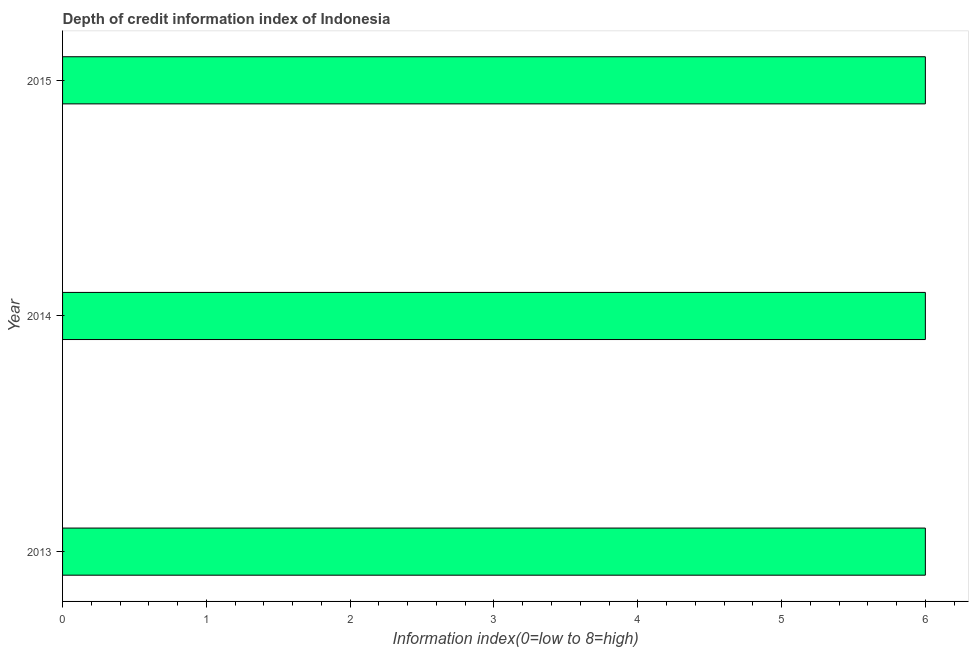Does the graph contain any zero values?
Your answer should be very brief. No. What is the title of the graph?
Your response must be concise. Depth of credit information index of Indonesia. What is the label or title of the X-axis?
Your answer should be very brief. Information index(0=low to 8=high). What is the label or title of the Y-axis?
Keep it short and to the point. Year. What is the depth of credit information index in 2013?
Your answer should be compact. 6. Across all years, what is the minimum depth of credit information index?
Give a very brief answer. 6. What is the average depth of credit information index per year?
Provide a short and direct response. 6. What is the median depth of credit information index?
Make the answer very short. 6. Do a majority of the years between 2014 and 2013 (inclusive) have depth of credit information index greater than 2.2 ?
Provide a short and direct response. No. What is the ratio of the depth of credit information index in 2013 to that in 2015?
Keep it short and to the point. 1. Is the depth of credit information index in 2014 less than that in 2015?
Offer a very short reply. No. Is the sum of the depth of credit information index in 2013 and 2015 greater than the maximum depth of credit information index across all years?
Keep it short and to the point. Yes. What is the difference between the highest and the lowest depth of credit information index?
Your answer should be compact. 0. In how many years, is the depth of credit information index greater than the average depth of credit information index taken over all years?
Make the answer very short. 0. How many bars are there?
Offer a very short reply. 3. How many years are there in the graph?
Provide a short and direct response. 3. Are the values on the major ticks of X-axis written in scientific E-notation?
Provide a short and direct response. No. What is the Information index(0=low to 8=high) in 2014?
Make the answer very short. 6. What is the difference between the Information index(0=low to 8=high) in 2013 and 2014?
Your response must be concise. 0. What is the difference between the Information index(0=low to 8=high) in 2013 and 2015?
Give a very brief answer. 0. What is the ratio of the Information index(0=low to 8=high) in 2013 to that in 2014?
Your answer should be very brief. 1. 